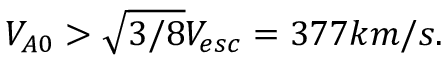Convert formula to latex. <formula><loc_0><loc_0><loc_500><loc_500>V _ { A 0 } > \sqrt { 3 / 8 } V _ { e s c } = 3 7 7 k m / s .</formula> 